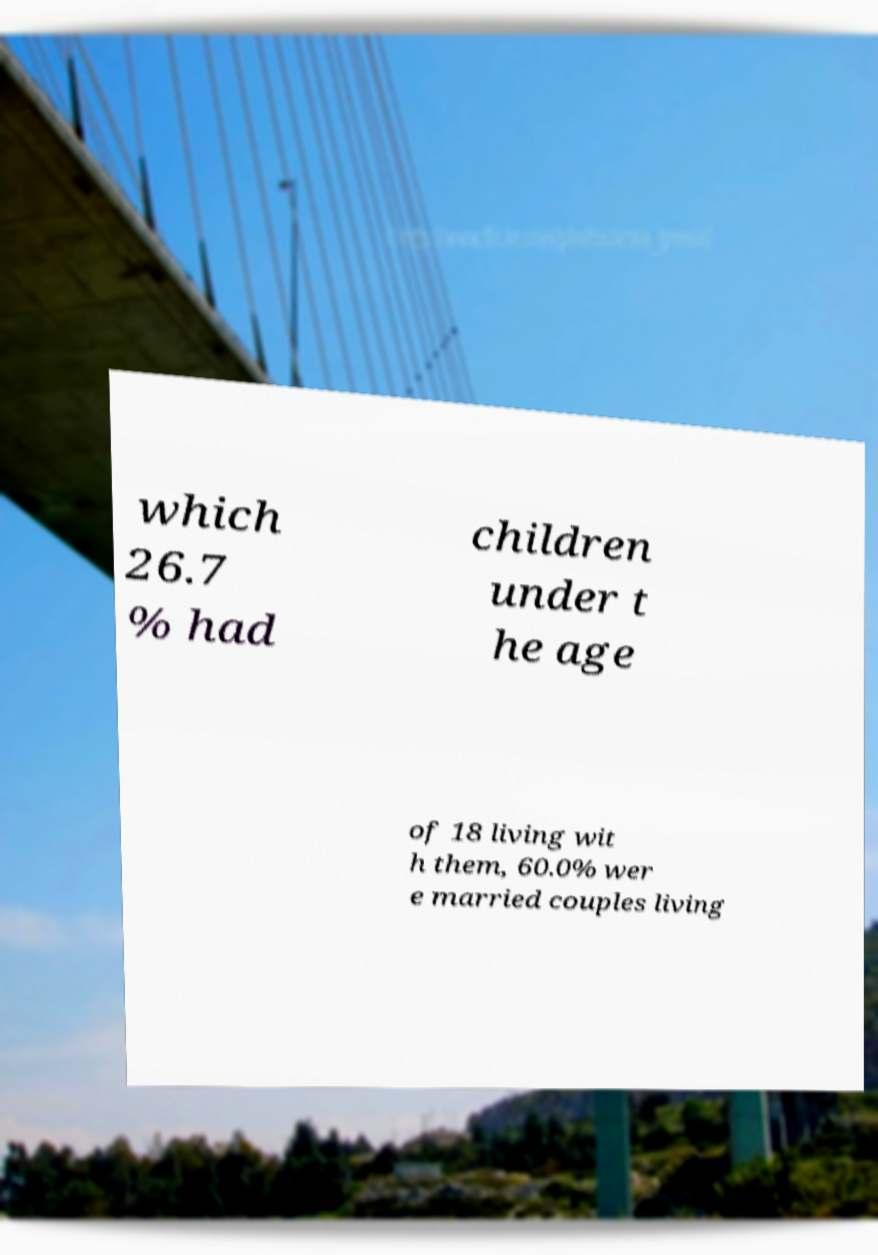Please identify and transcribe the text found in this image. which 26.7 % had children under t he age of 18 living wit h them, 60.0% wer e married couples living 